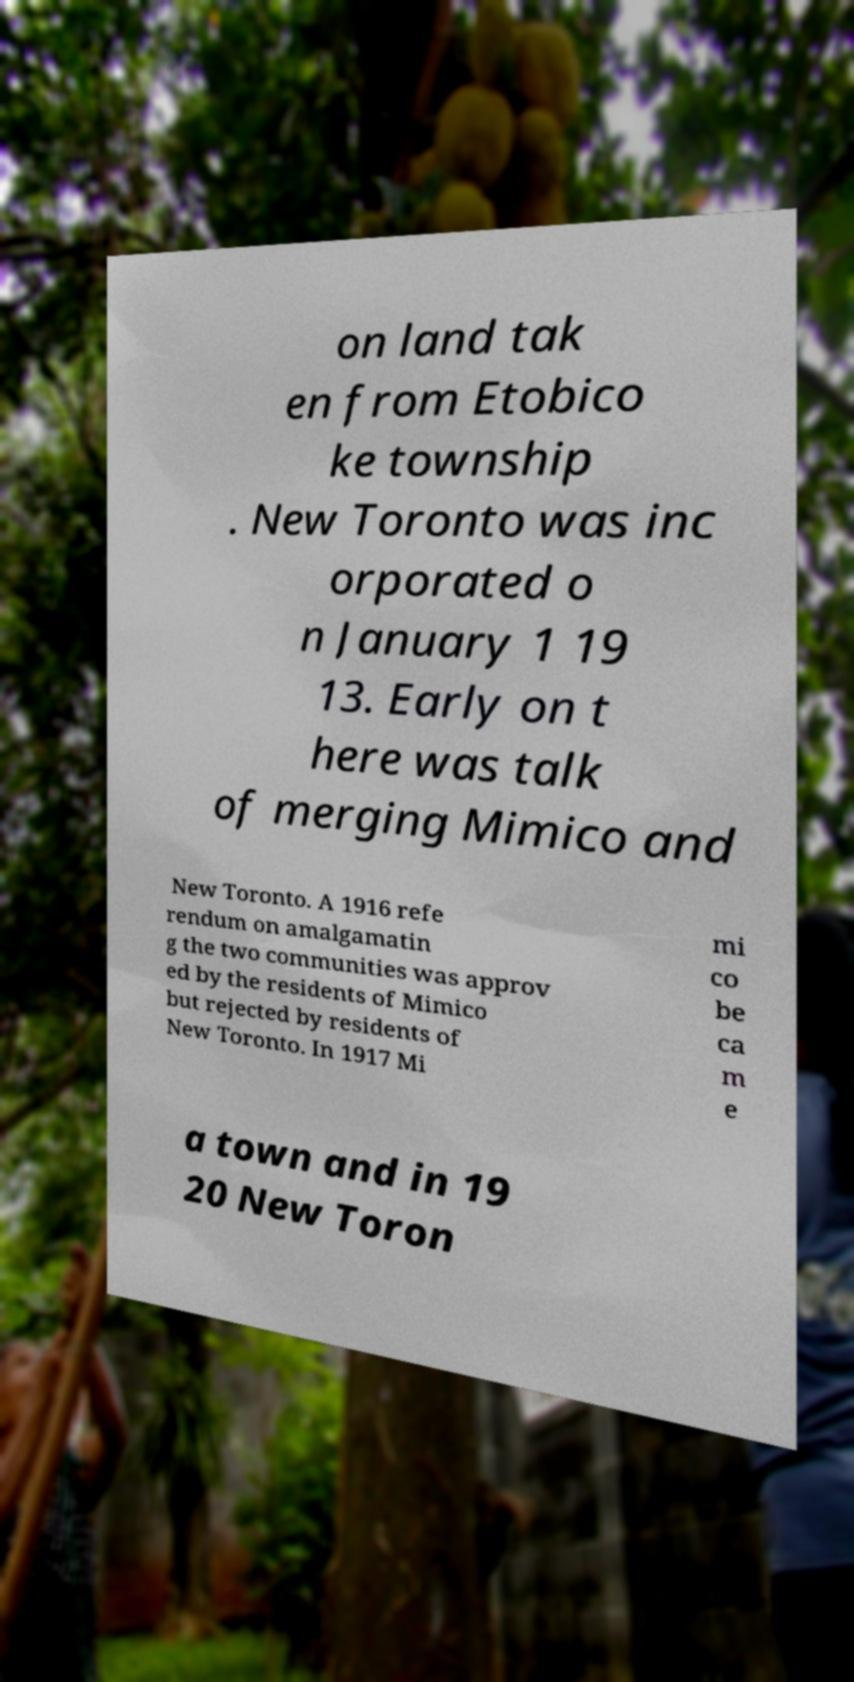For documentation purposes, I need the text within this image transcribed. Could you provide that? on land tak en from Etobico ke township . New Toronto was inc orporated o n January 1 19 13. Early on t here was talk of merging Mimico and New Toronto. A 1916 refe rendum on amalgamatin g the two communities was approv ed by the residents of Mimico but rejected by residents of New Toronto. In 1917 Mi mi co be ca m e a town and in 19 20 New Toron 